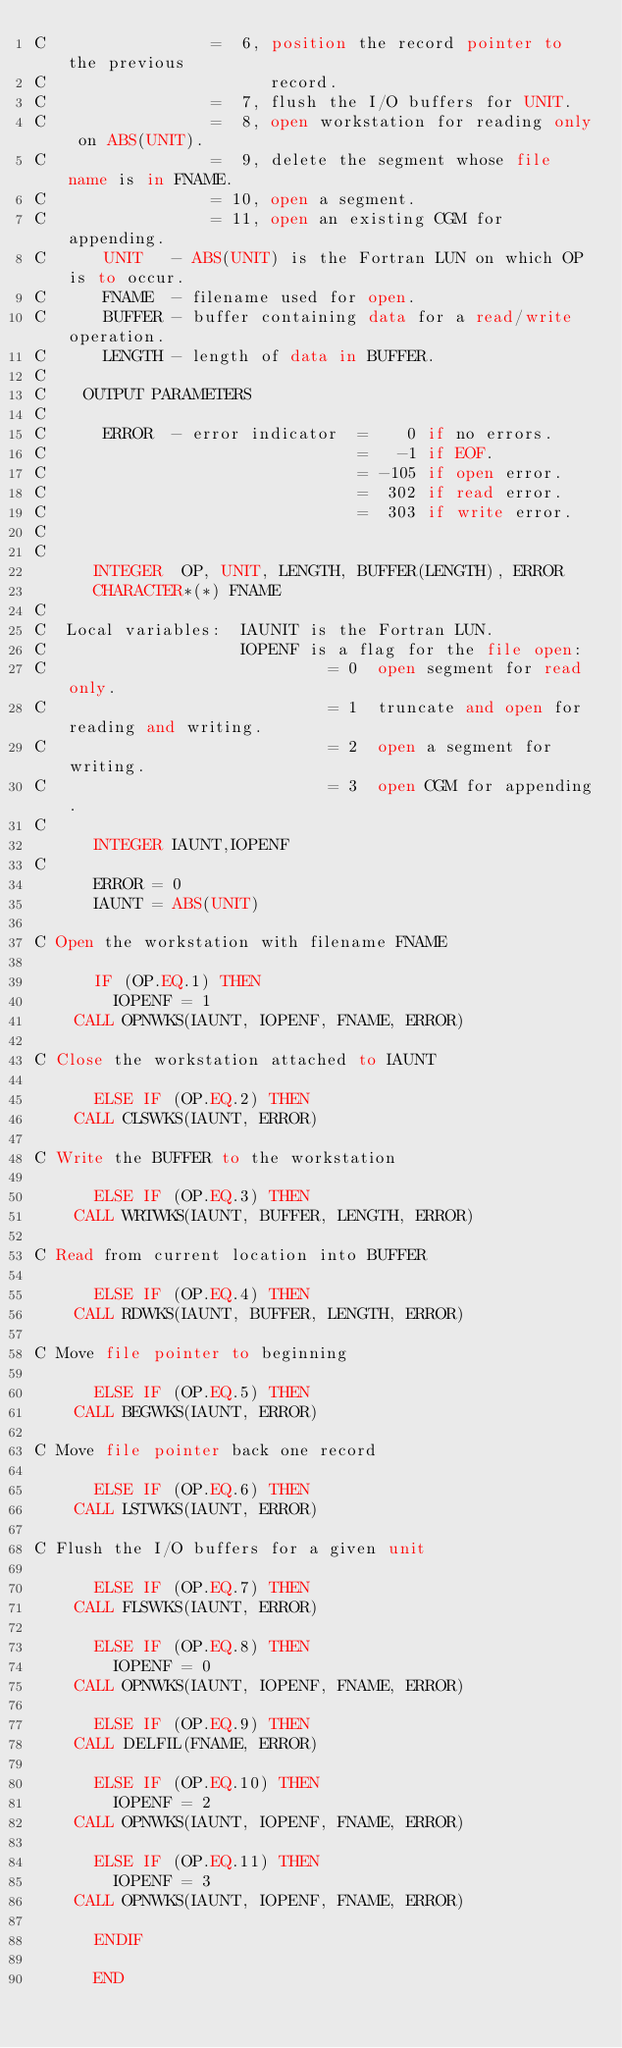Convert code to text. <code><loc_0><loc_0><loc_500><loc_500><_FORTRAN_>C                 =  6, position the record pointer to the previous 
C                       record.
C                 =  7, flush the I/O buffers for UNIT.
C                 =  8, open workstation for reading only on ABS(UNIT).
C                 =  9, delete the segment whose file name is in FNAME.
C                 = 10, open a segment.
C                 = 11, open an existing CGM for appending.
C      UNIT   - ABS(UNIT) is the Fortran LUN on which OP is to occur.
C      FNAME  - filename used for open.
C      BUFFER - buffer containing data for a read/write operation.
C      LENGTH - length of data in BUFFER.
C
C    OUTPUT PARAMETERS
C
C      ERROR  - error indicator  =    0 if no errors.
C                                =   -1 if EOF.
C                                = -105 if open error.
C                                =  302 if read error.
C                                =  303 if write error.
C
C
      INTEGER  OP, UNIT, LENGTH, BUFFER(LENGTH), ERROR
      CHARACTER*(*) FNAME
C
C  Local variables:  IAUNIT is the Fortran LUN.
C                    IOPENF is a flag for the file open:
C                             = 0  open segment for read only.
C                             = 1  truncate and open for reading and writing.
C                             = 2  open a segment for writing.
C                             = 3  open CGM for appending.
C
      INTEGER IAUNT,IOPENF
C
      ERROR = 0
      IAUNT = ABS(UNIT)

C Open the workstation with filename FNAME

      IF (OP.EQ.1) THEN
        IOPENF = 1
	CALL OPNWKS(IAUNT, IOPENF, FNAME, ERROR)

C Close the workstation attached to IAUNT

      ELSE IF (OP.EQ.2) THEN
	CALL CLSWKS(IAUNT, ERROR)

C Write the BUFFER to the workstation

      ELSE IF (OP.EQ.3) THEN
	CALL WRTWKS(IAUNT, BUFFER, LENGTH, ERROR)

C Read from current location into BUFFER

      ELSE IF (OP.EQ.4) THEN
	CALL RDWKS(IAUNT, BUFFER, LENGTH, ERROR)

C Move file pointer to beginning

      ELSE IF (OP.EQ.5) THEN
	CALL BEGWKS(IAUNT, ERROR)

C Move file pointer back one record

      ELSE IF (OP.EQ.6) THEN
	CALL LSTWKS(IAUNT, ERROR)

C Flush the I/O buffers for a given unit

      ELSE IF (OP.EQ.7) THEN
	CALL FLSWKS(IAUNT, ERROR)

      ELSE IF (OP.EQ.8) THEN
        IOPENF = 0
	CALL OPNWKS(IAUNT, IOPENF, FNAME, ERROR)

      ELSE IF (OP.EQ.9) THEN
	CALL DELFIL(FNAME, ERROR)

      ELSE IF (OP.EQ.10) THEN
        IOPENF = 2
	CALL OPNWKS(IAUNT, IOPENF, FNAME, ERROR)

      ELSE IF (OP.EQ.11) THEN
        IOPENF = 3
	CALL OPNWKS(IAUNT, IOPENF, FNAME, ERROR)

      ENDIF

      END
</code> 